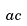<formula> <loc_0><loc_0><loc_500><loc_500>a c</formula> 